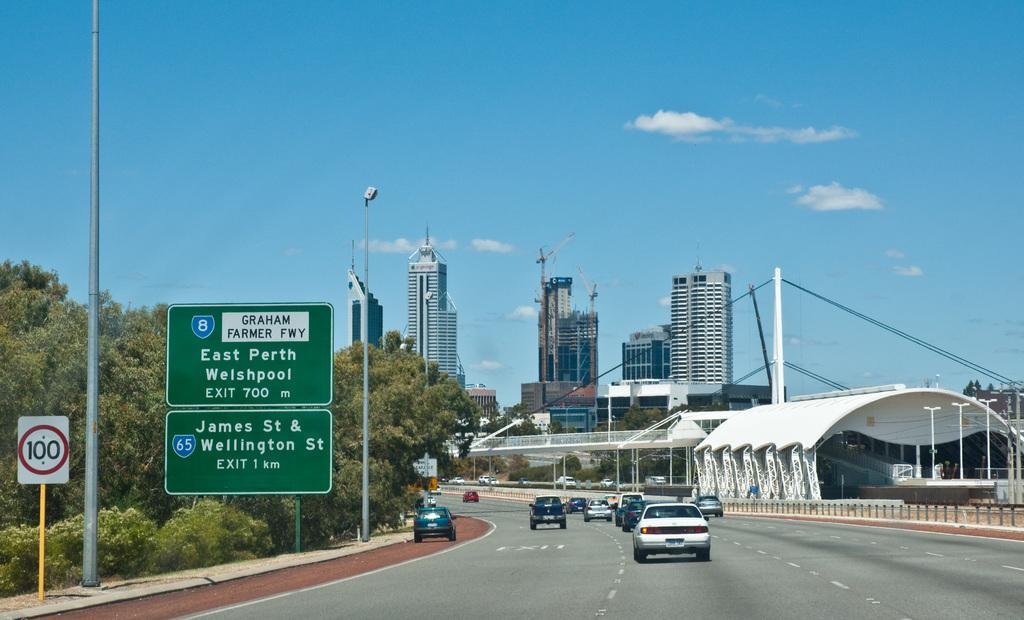<image>
Write a terse but informative summary of the picture. a sign that has the number 100 on it and many buildings 